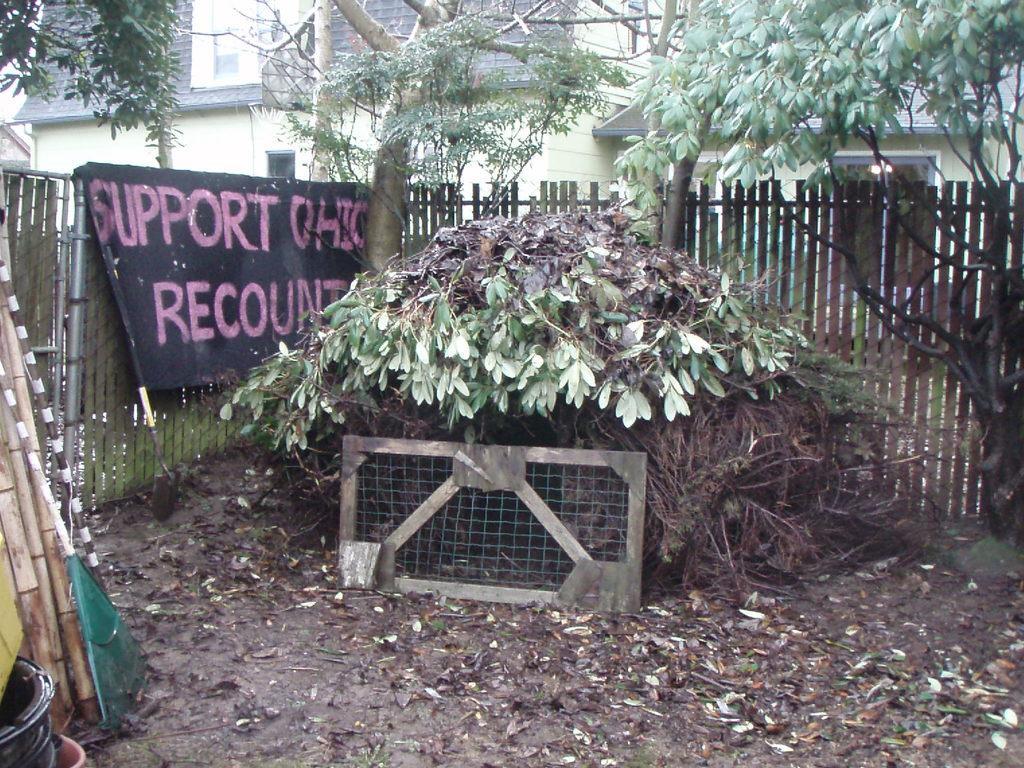Can you describe this image briefly? In this picture I can see the trees. I can see the wooden fence in the foreground. I can see the banner on the left side. I can see the buildings in the background. 